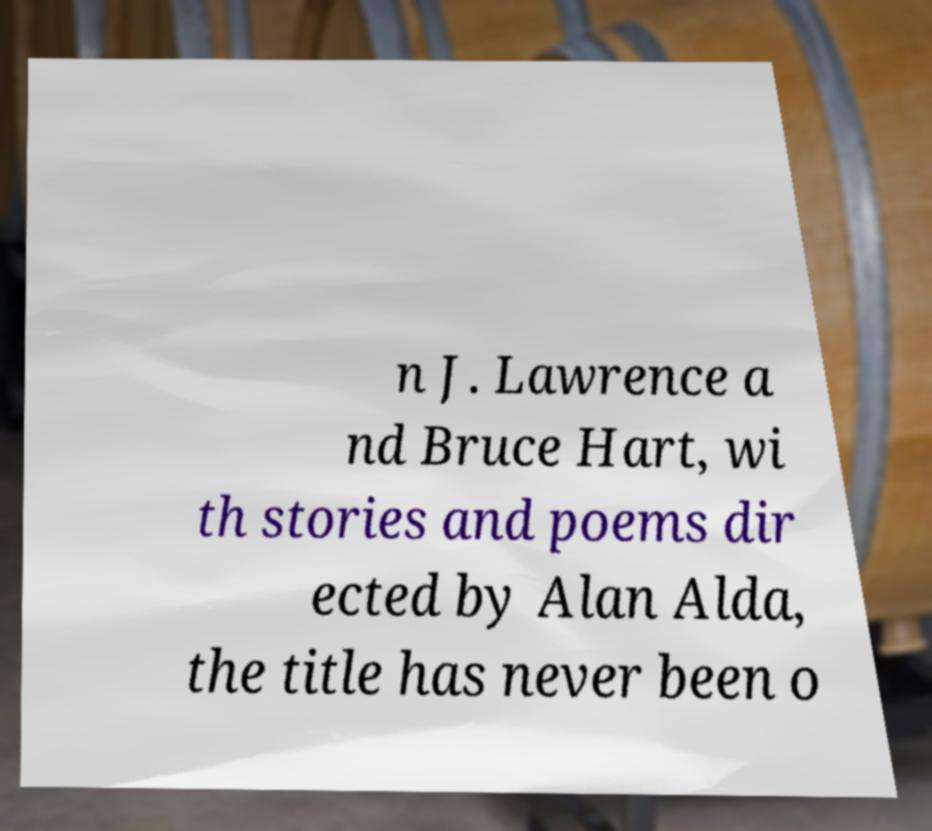Can you read and provide the text displayed in the image?This photo seems to have some interesting text. Can you extract and type it out for me? n J. Lawrence a nd Bruce Hart, wi th stories and poems dir ected by Alan Alda, the title has never been o 